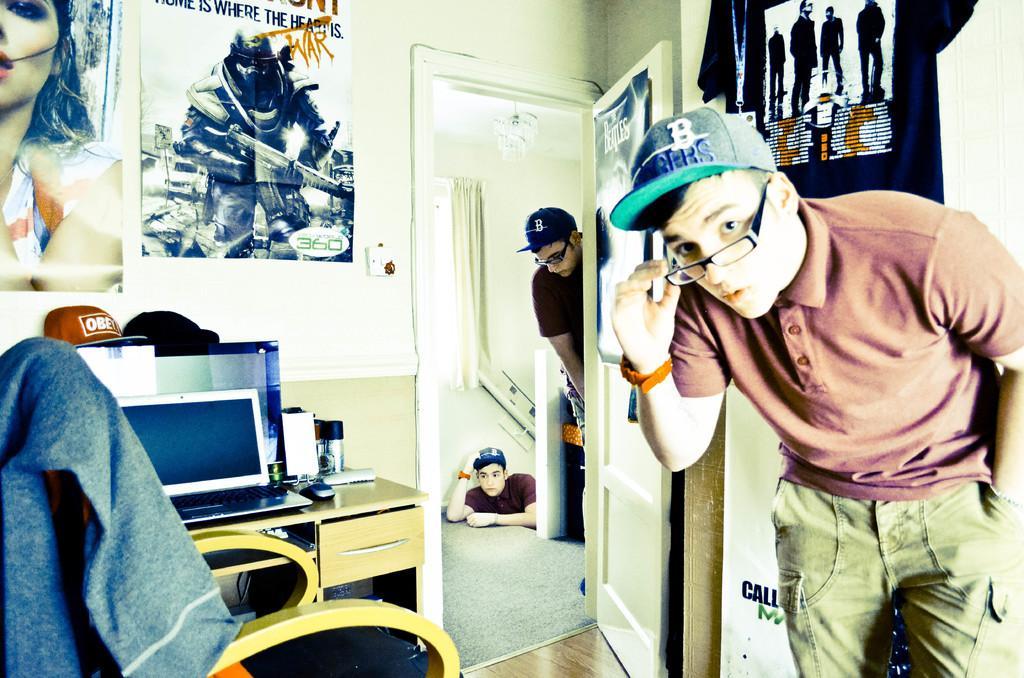Describe this image in one or two sentences. In this picture there is a boy wearing a spectacles and hat, standing in the room. In the right side there is a chair and a table on which a computer was placed. There are some posters attached to the wall here. In the background there are two members. One is in the, on the stairs and the other is behind the door. There are curtains and a wall here. 